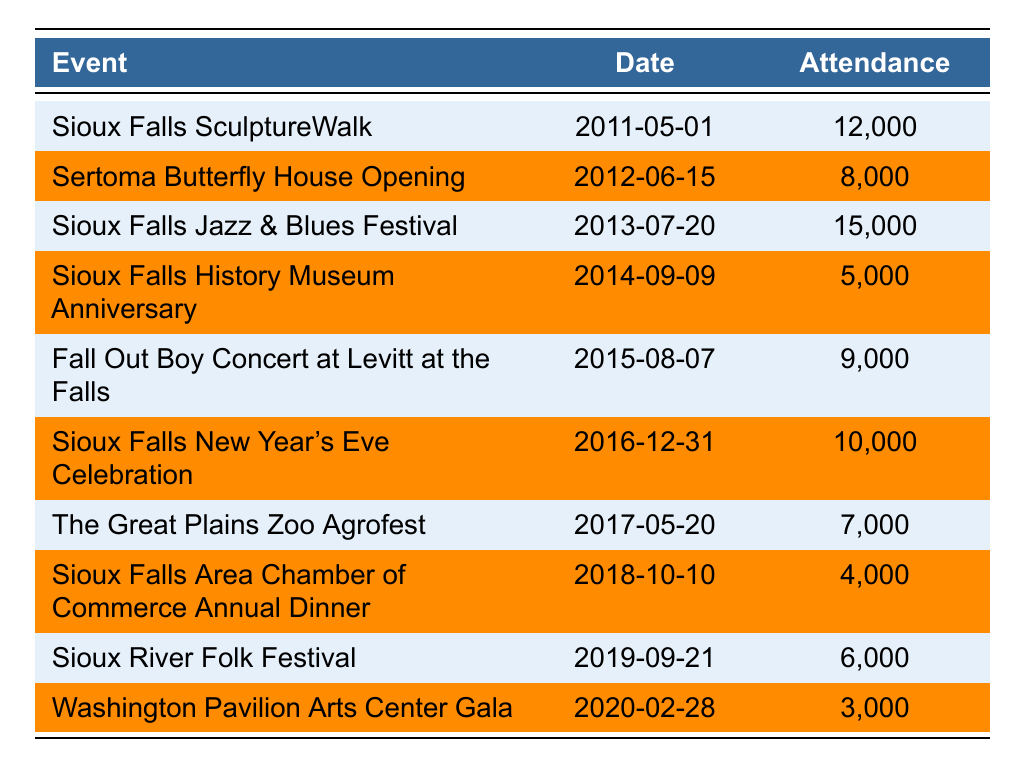What was the attendance for the Sioux Falls Jazz & Blues Festival? The name of the event is listed in the table, and the corresponding attendance is 15,000.
Answer: 15,000 Which event had the lowest attendance? By reviewing the attendance numbers in the table, the Washington Pavilion Arts Center Gala had the lowest attendance at 3,000.
Answer: 3,000 What was the attendance difference between the Sioux Falls SculptureWalk and the Sioux Falls History Museum Anniversary? The attendance for the Sioux Falls SculptureWalk was 12,000 and for the Sioux Falls History Museum Anniversary was 5,000. The difference is 12,000 - 5,000 = 7,000.
Answer: 7,000 How many events had an attendance of more than 10,000 people? Checking the attendance numbers, the events with more than 10,000 attendees are the Sioux Falls SculptureWalk (12,000), Sioux Falls Jazz & Blues Festival (15,000), and Sioux Falls New Year's Eve Celebration (10,000). There are three such events.
Answer: 3 What was the average attendance for events held between 2015 and 2020? The events during this period are: Fall Out Boy Concert (9,000), Sioux Falls New Year's Eve Celebration (10,000), The Great Plains Zoo Agrofest (7,000), Sioux Falls Area Chamber of Commerce Annual Dinner (4,000), Sioux River Folk Festival (6,000), Washington Pavilion Arts Center Gala (3,000). The sum is 39,000 and the average is 39,000/6 = 6,500.
Answer: 6,500 Did any event have an attendance of exactly 8,000? The Sertoma Butterfly House Opening had an attendance of 8,000, confirming that there was one event with this exact attendance.
Answer: Yes Which event experienced a decline in attendance compared to the previous year? The data shows that the attendance for the Sioux Falls Area Chamber of Commerce Annual Dinner (4,000) in 2018 is lower than the attendance for the previous event, The Great Plains Zoo Agrofest (7,000) in 2017. This indicates a decline.
Answer: Yes What is the total attendance for events held in 2012, 2014, and 2016? The attendance for Sertoma Butterfly House Opening in 2012 is 8,000, for Sioux Falls History Museum Anniversary in 2014 is 5,000, and for Sioux Falls New Year's Eve Celebration in 2016 is 10,000. The total is 8,000 + 5,000 + 10,000 = 23,000.
Answer: 23,000 Which year had the highest attendance event? By checking the attendance figures, the Sioux Falls Jazz & Blues Festival in 2013 had the highest attendance of 15,000 compared to other years.
Answer: 2013 